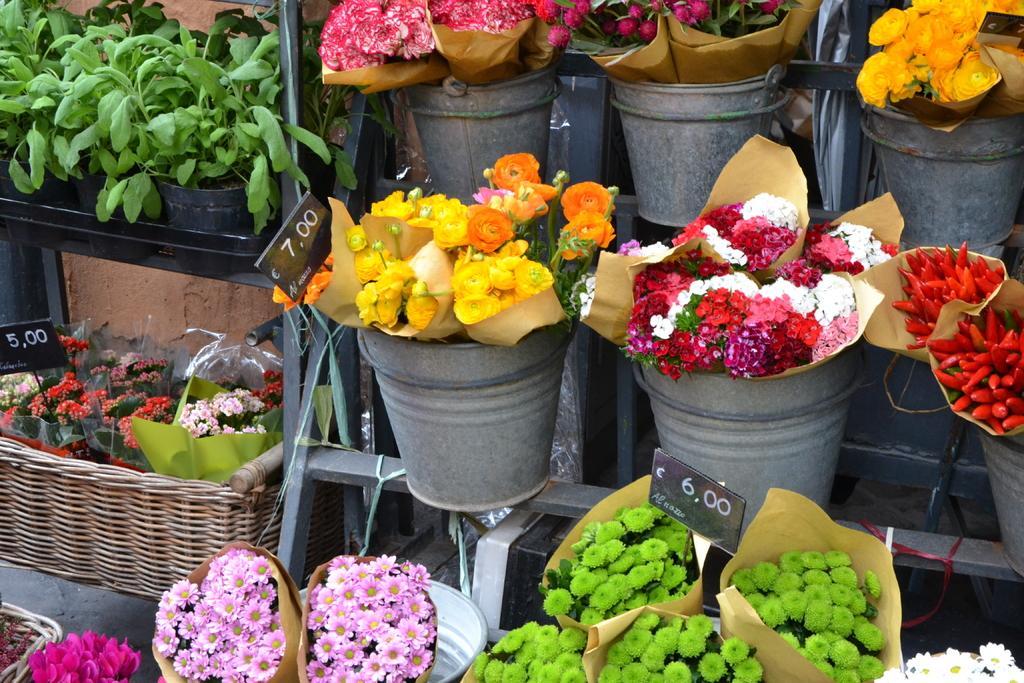In one or two sentences, can you explain what this image depicts? Here I can see some flower pots on a stand. The flowers are in different colors. On the left side, I can see a basket in which flower bouquets are arranged. On the top of it I can see some plants in green color. 